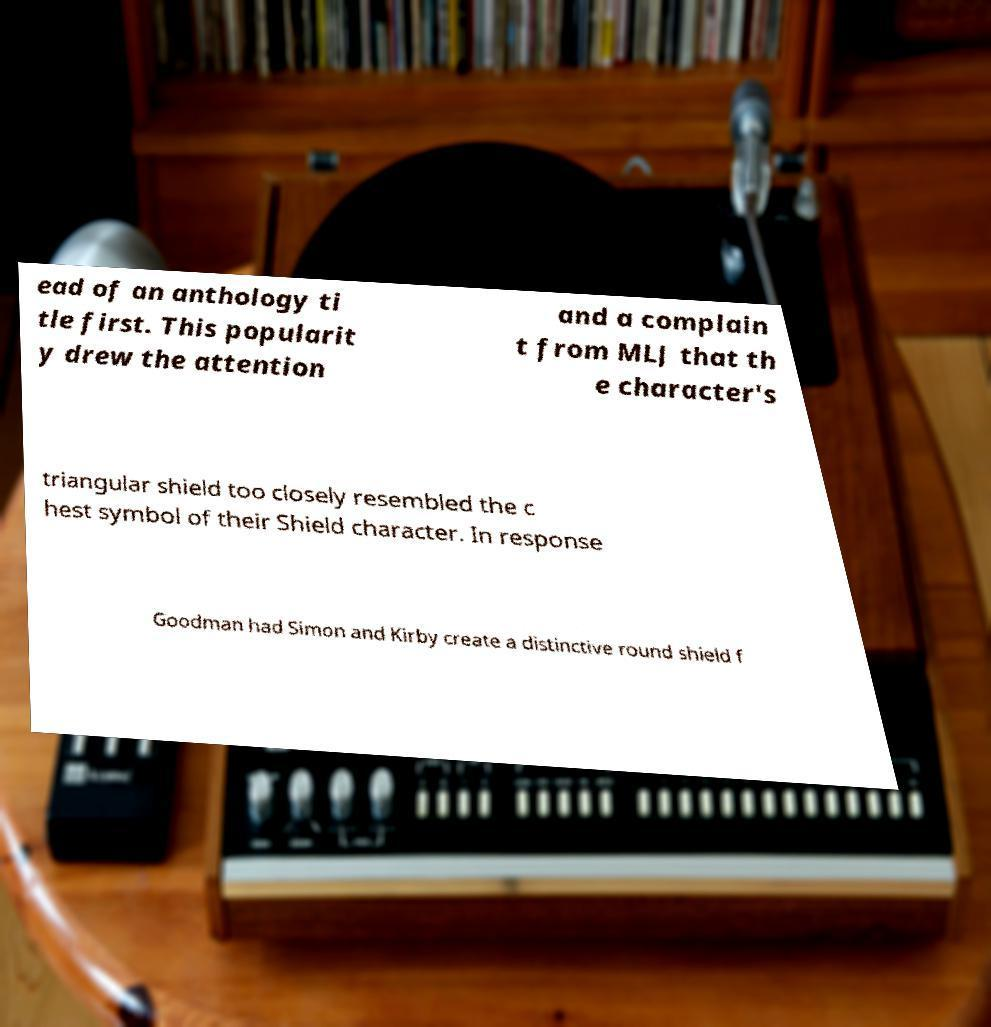There's text embedded in this image that I need extracted. Can you transcribe it verbatim? ead of an anthology ti tle first. This popularit y drew the attention and a complain t from MLJ that th e character's triangular shield too closely resembled the c hest symbol of their Shield character. In response Goodman had Simon and Kirby create a distinctive round shield f 